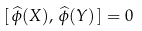Convert formula to latex. <formula><loc_0><loc_0><loc_500><loc_500>[ \, \widehat { \phi } ( X ) , \, \widehat { \phi } ( Y ) \, ] = 0</formula> 